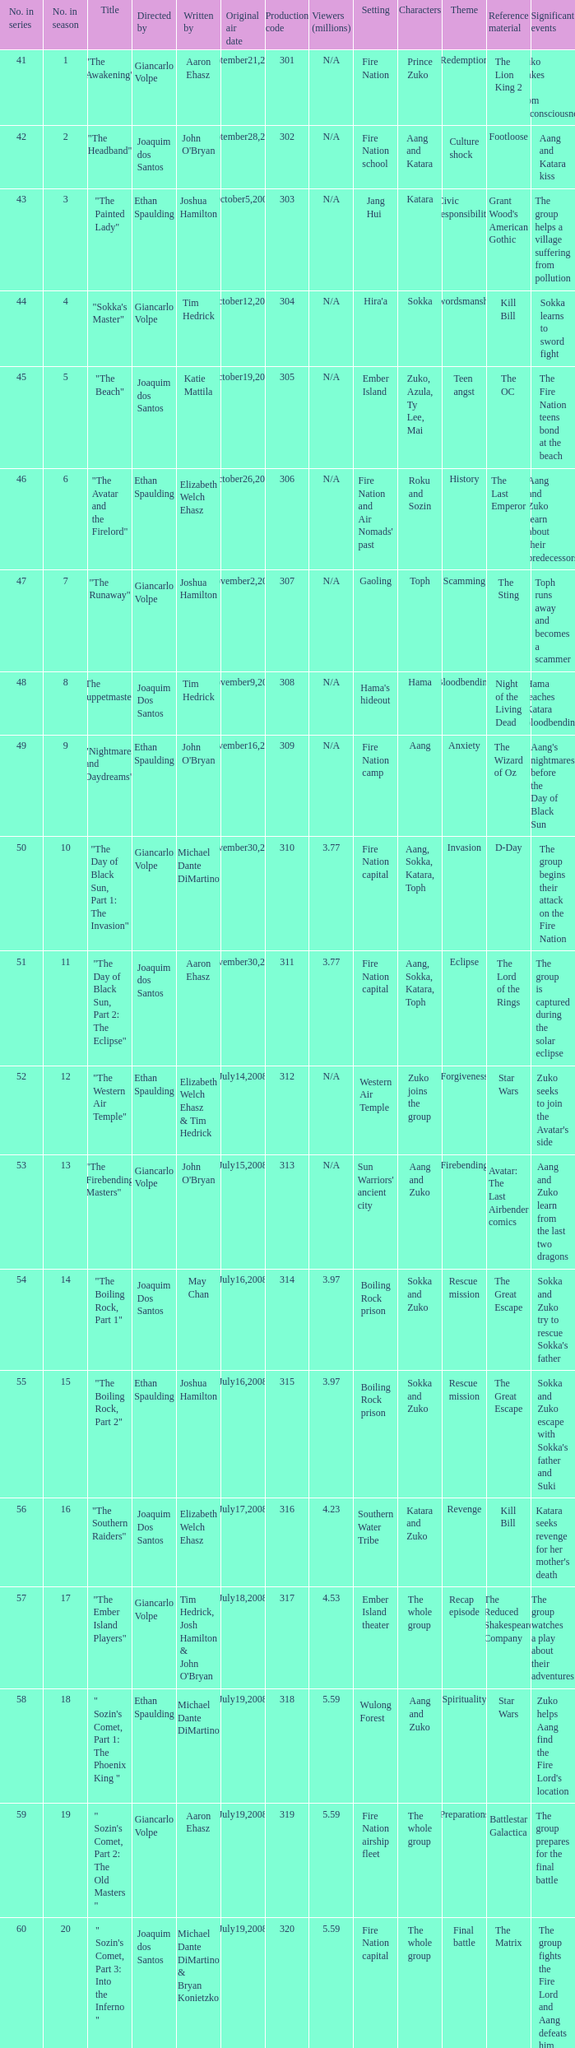What is the original air date for the episode with a production code of 318? July19,2008. 